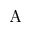Convert formula to latex. <formula><loc_0><loc_0><loc_500><loc_500>A</formula> 